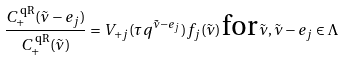Convert formula to latex. <formula><loc_0><loc_0><loc_500><loc_500>\frac { C ^ { \text { qR} } _ { + } ( \tilde { \nu } - e _ { j } ) } { C ^ { \text { qR} } _ { + } ( \tilde { \nu } ) } = V _ { + j } ( \tau q ^ { \tilde { \nu } - e _ { j } } ) f _ { j } ( \tilde { \nu } ) \, \text {for} \, \tilde { \nu } , \tilde { \nu } - e _ { j } \in \Lambda</formula> 